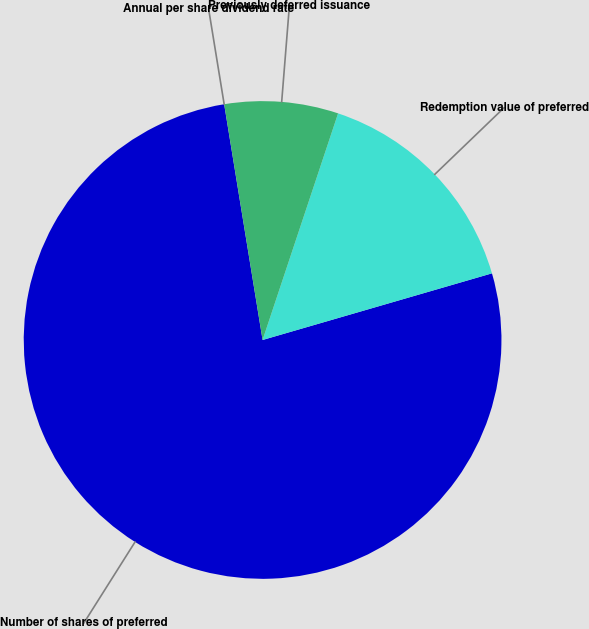<chart> <loc_0><loc_0><loc_500><loc_500><pie_chart><fcel>Annual per share dividend rate<fcel>Number of shares of preferred<fcel>Redemption value of preferred<fcel>Previously deferred issuance<nl><fcel>0.0%<fcel>76.92%<fcel>15.38%<fcel>7.69%<nl></chart> 